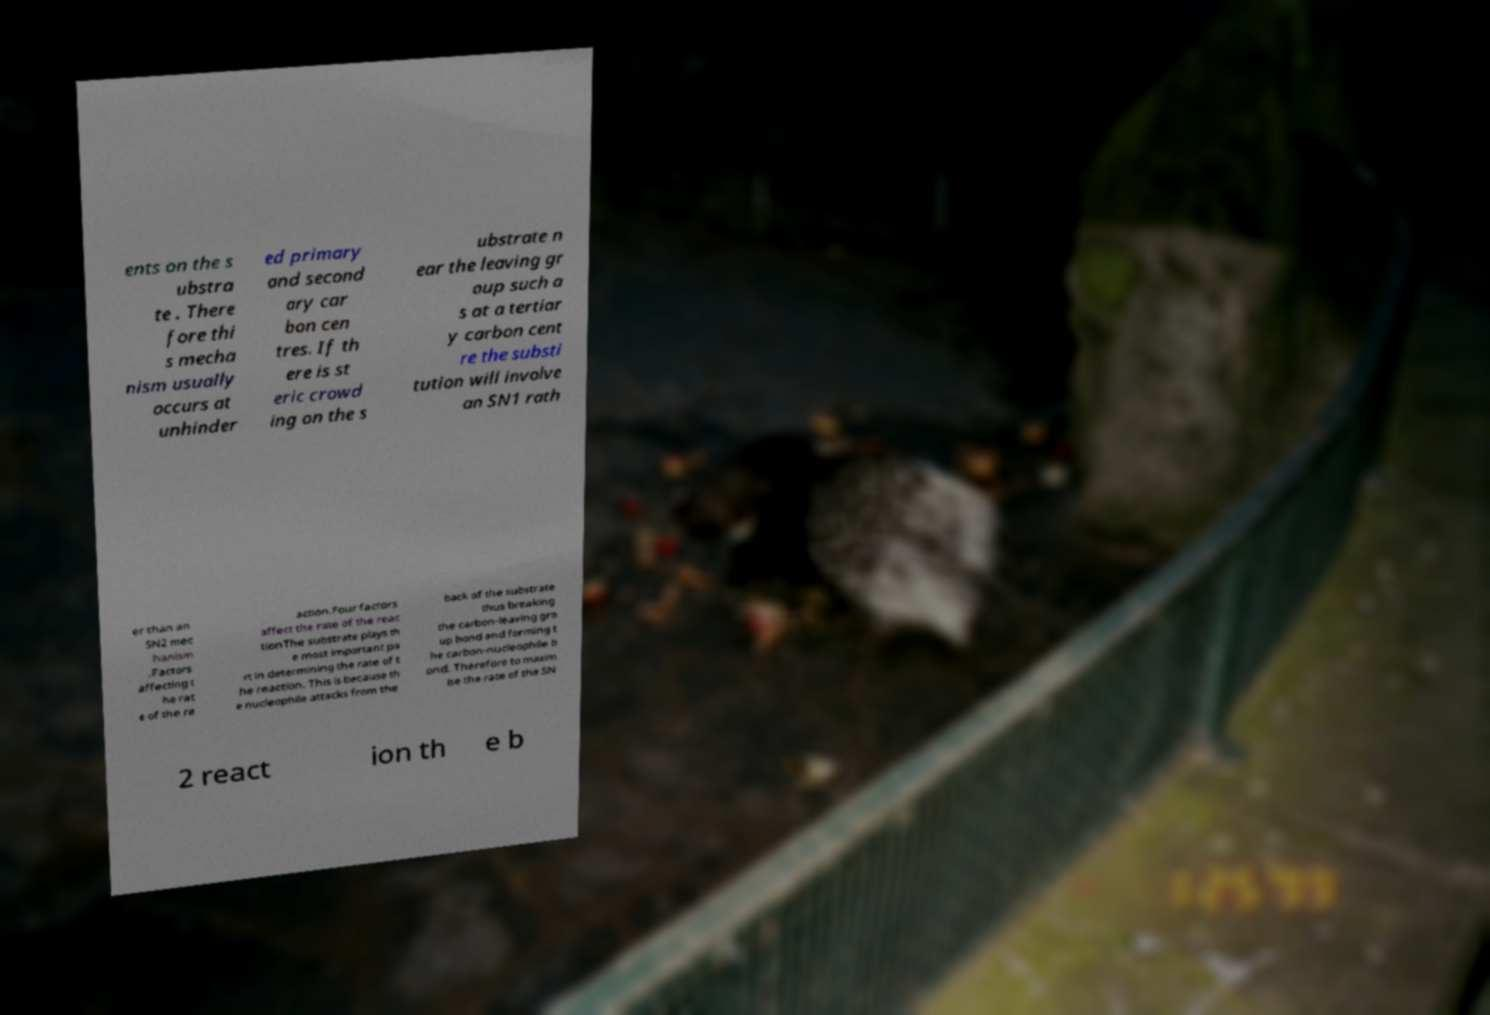Can you read and provide the text displayed in the image?This photo seems to have some interesting text. Can you extract and type it out for me? ents on the s ubstra te . There fore thi s mecha nism usually occurs at unhinder ed primary and second ary car bon cen tres. If th ere is st eric crowd ing on the s ubstrate n ear the leaving gr oup such a s at a tertiar y carbon cent re the substi tution will involve an SN1 rath er than an SN2 mec hanism .Factors affecting t he rat e of the re action.Four factors affect the rate of the reac tionThe substrate plays th e most important pa rt in determining the rate of t he reaction. This is because th e nucleophile attacks from the back of the substrate thus breaking the carbon-leaving gro up bond and forming t he carbon-nucleophile b ond. Therefore to maxim ise the rate of the SN 2 react ion th e b 